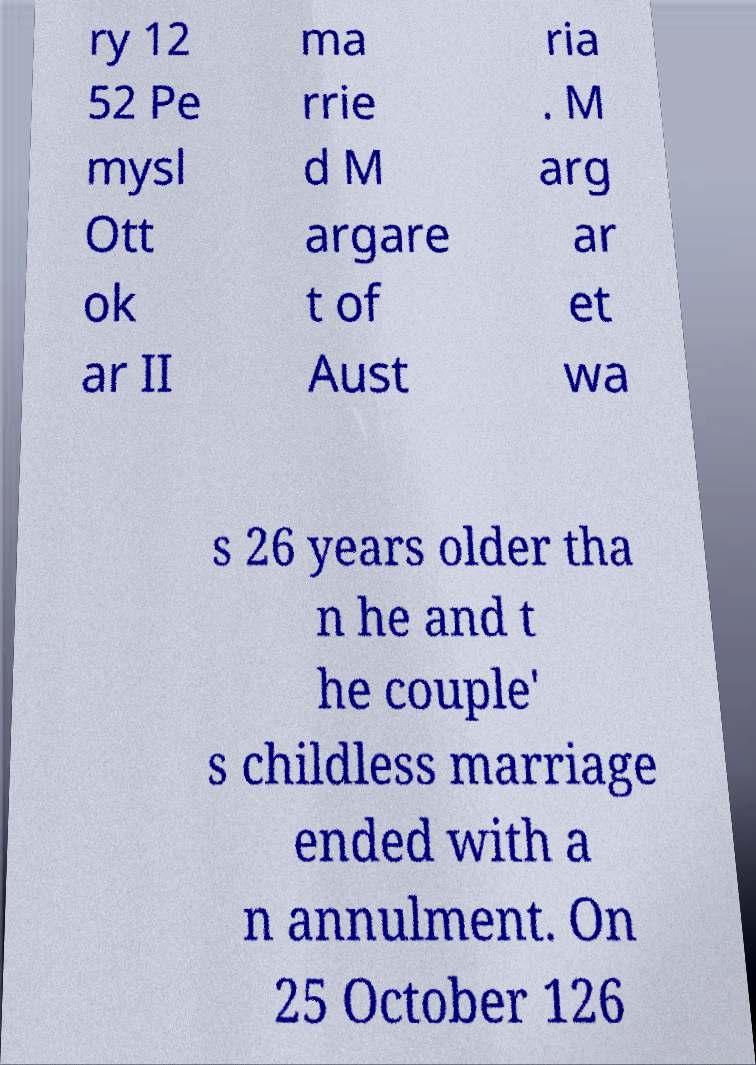There's text embedded in this image that I need extracted. Can you transcribe it verbatim? ry 12 52 Pe mysl Ott ok ar II ma rrie d M argare t of Aust ria . M arg ar et wa s 26 years older tha n he and t he couple' s childless marriage ended with a n annulment. On 25 October 126 